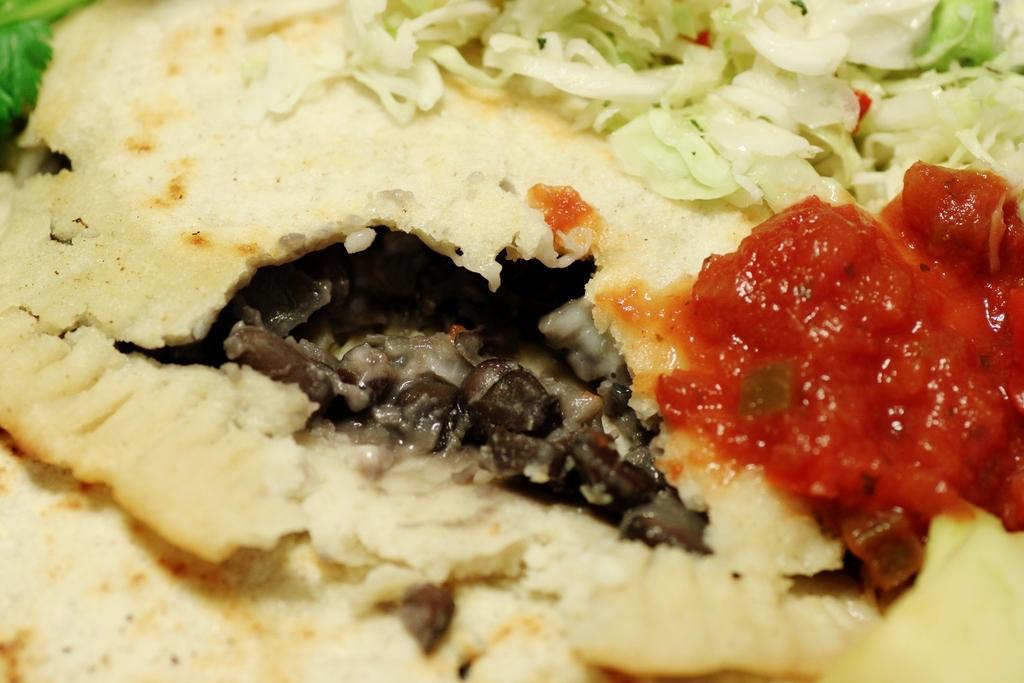In one or two sentences, can you explain what this image depicts? In this picture I can see the food in front and I see that, it is of cream, green, grey and red color. 